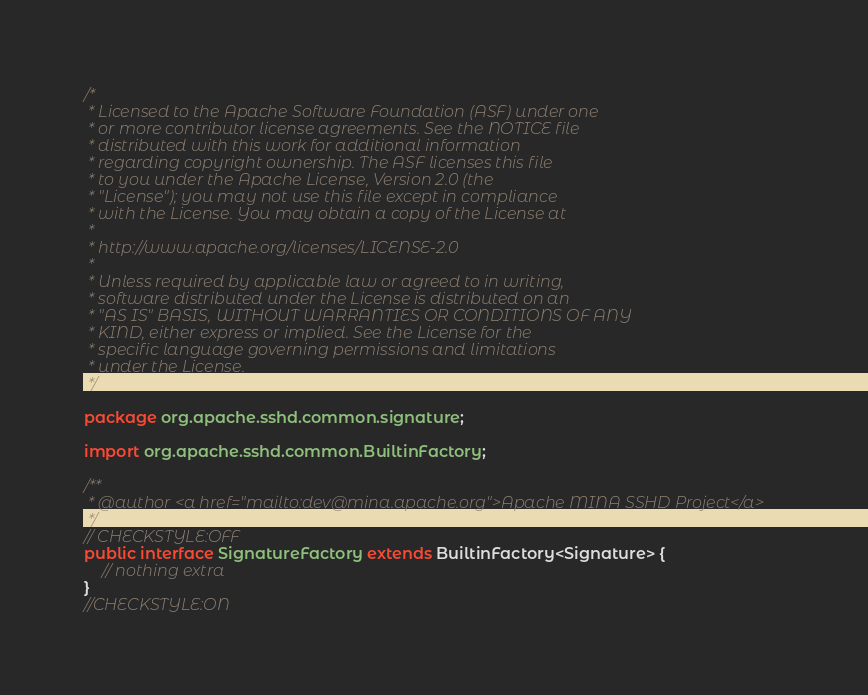<code> <loc_0><loc_0><loc_500><loc_500><_Java_>/*
 * Licensed to the Apache Software Foundation (ASF) under one
 * or more contributor license agreements. See the NOTICE file
 * distributed with this work for additional information
 * regarding copyright ownership. The ASF licenses this file
 * to you under the Apache License, Version 2.0 (the
 * "License"); you may not use this file except in compliance
 * with the License. You may obtain a copy of the License at
 *
 * http://www.apache.org/licenses/LICENSE-2.0
 *
 * Unless required by applicable law or agreed to in writing,
 * software distributed under the License is distributed on an
 * "AS IS" BASIS, WITHOUT WARRANTIES OR CONDITIONS OF ANY
 * KIND, either express or implied. See the License for the
 * specific language governing permissions and limitations
 * under the License.
 */

package org.apache.sshd.common.signature;

import org.apache.sshd.common.BuiltinFactory;

/**
 * @author <a href="mailto:dev@mina.apache.org">Apache MINA SSHD Project</a>
 */
// CHECKSTYLE:OFF
public interface SignatureFactory extends BuiltinFactory<Signature> {
    // nothing extra
}
//CHECKSTYLE:ON
</code> 